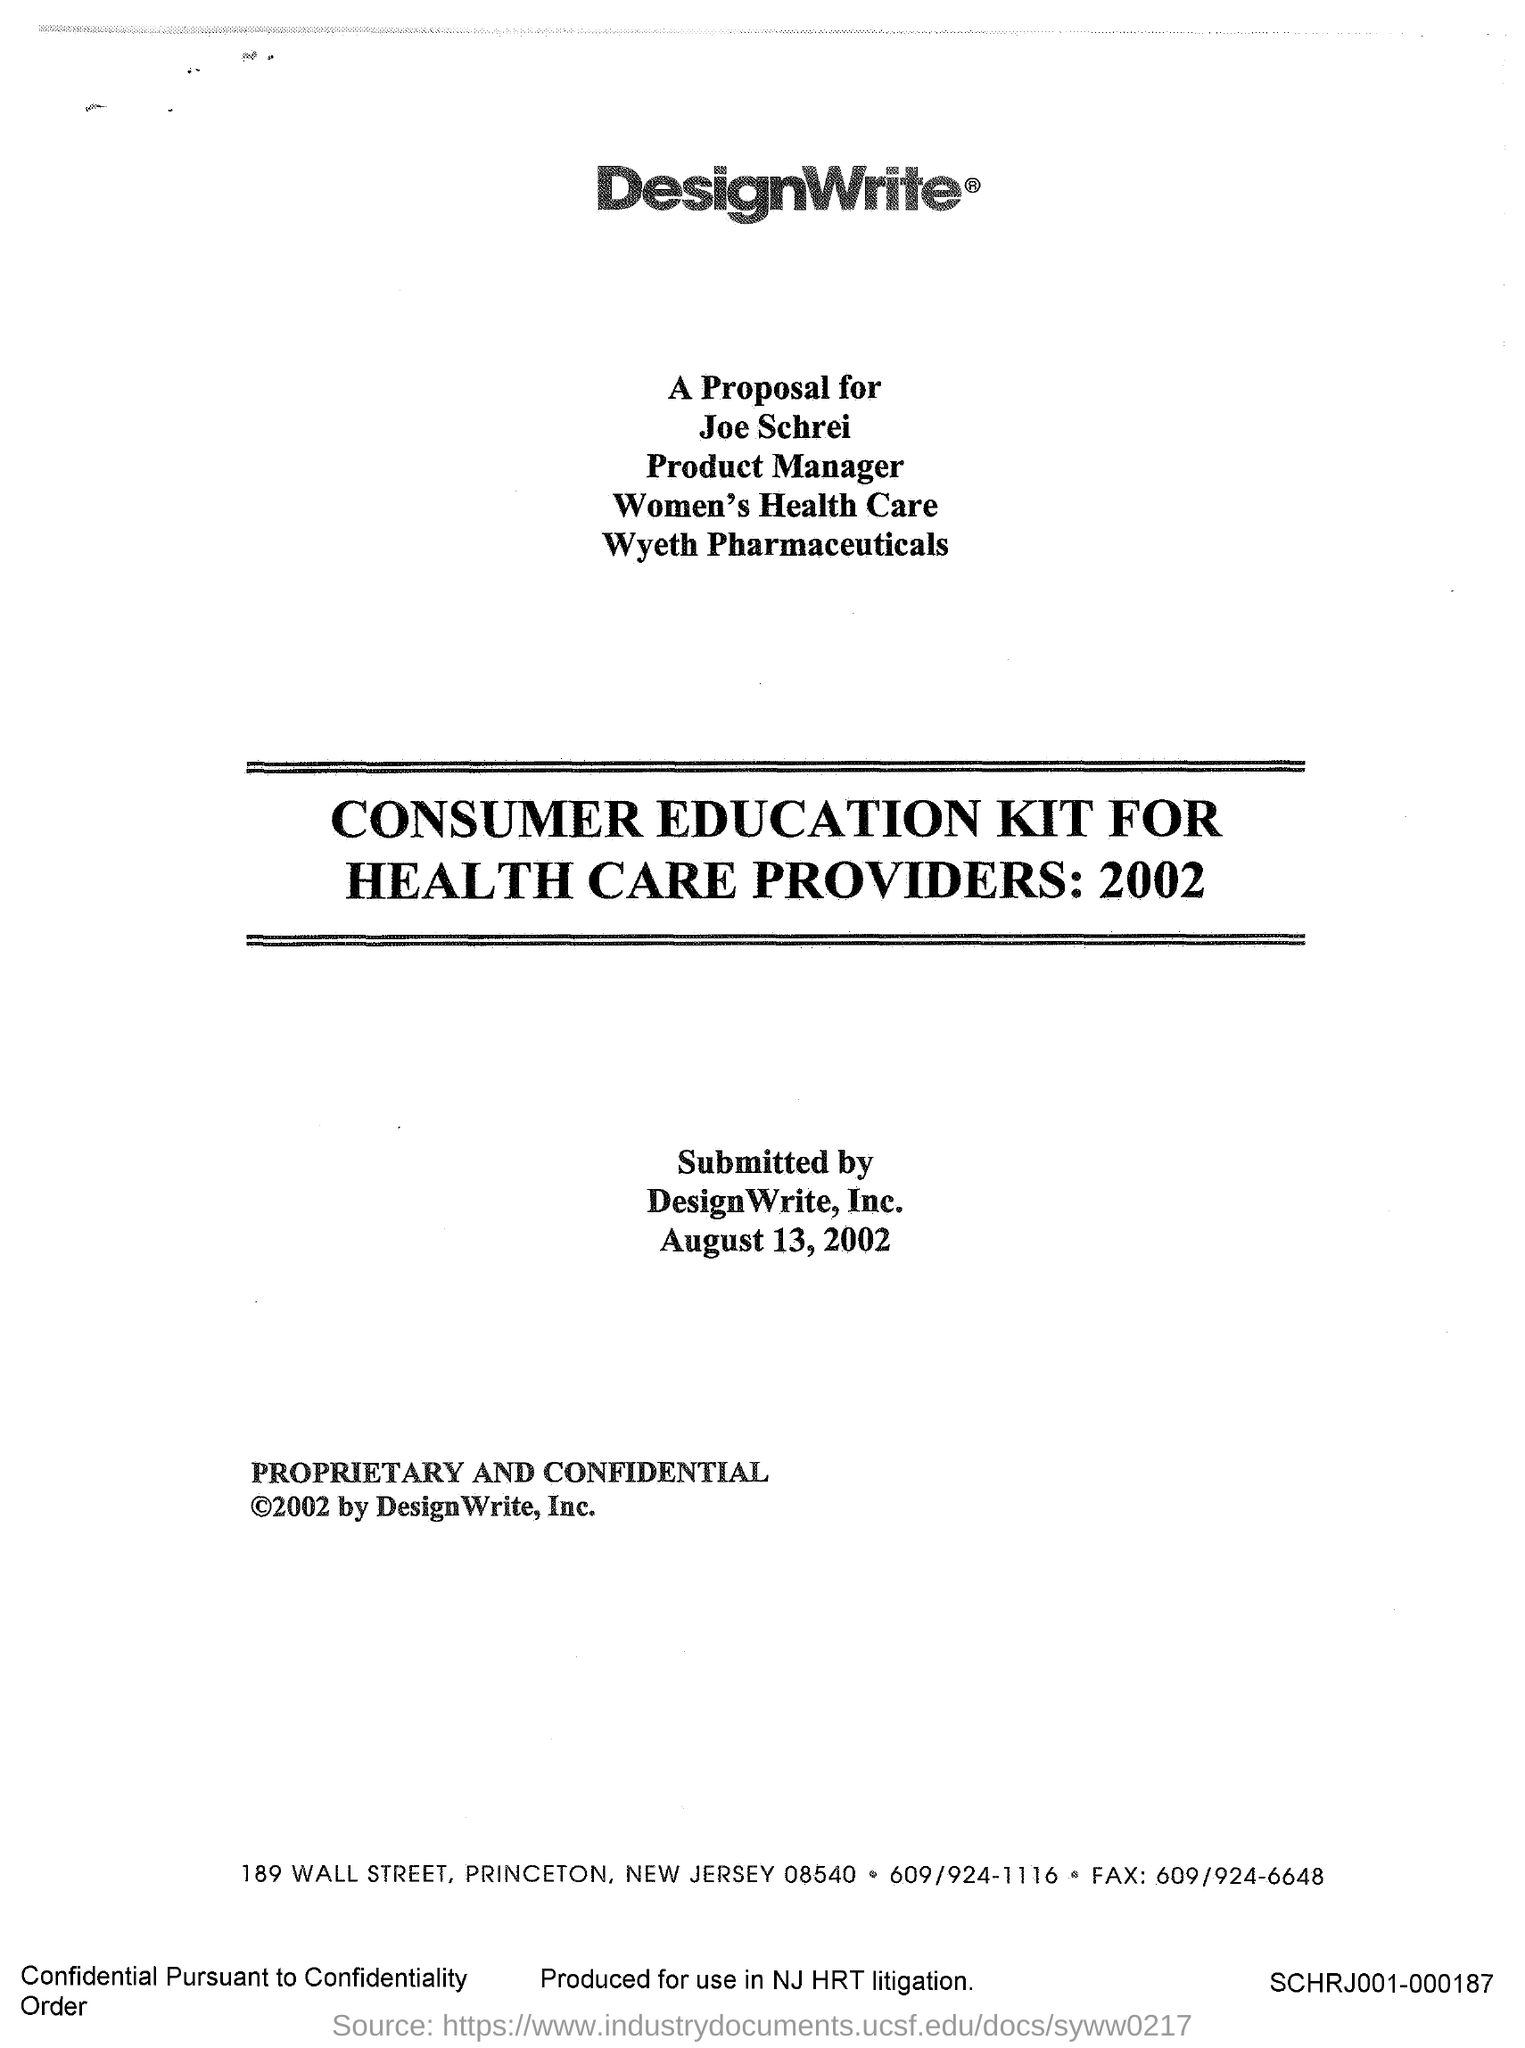Mention a couple of crucial points in this snapshot. The street address of DesignWrite is located at 189 Wall Street. The Consumer Health Education Kit is intended for health care providers. The proposal is addressed to JOE SCHREI. The Consumer Education Kit was first released in the year 2002. Designwrite is the name of the company. 